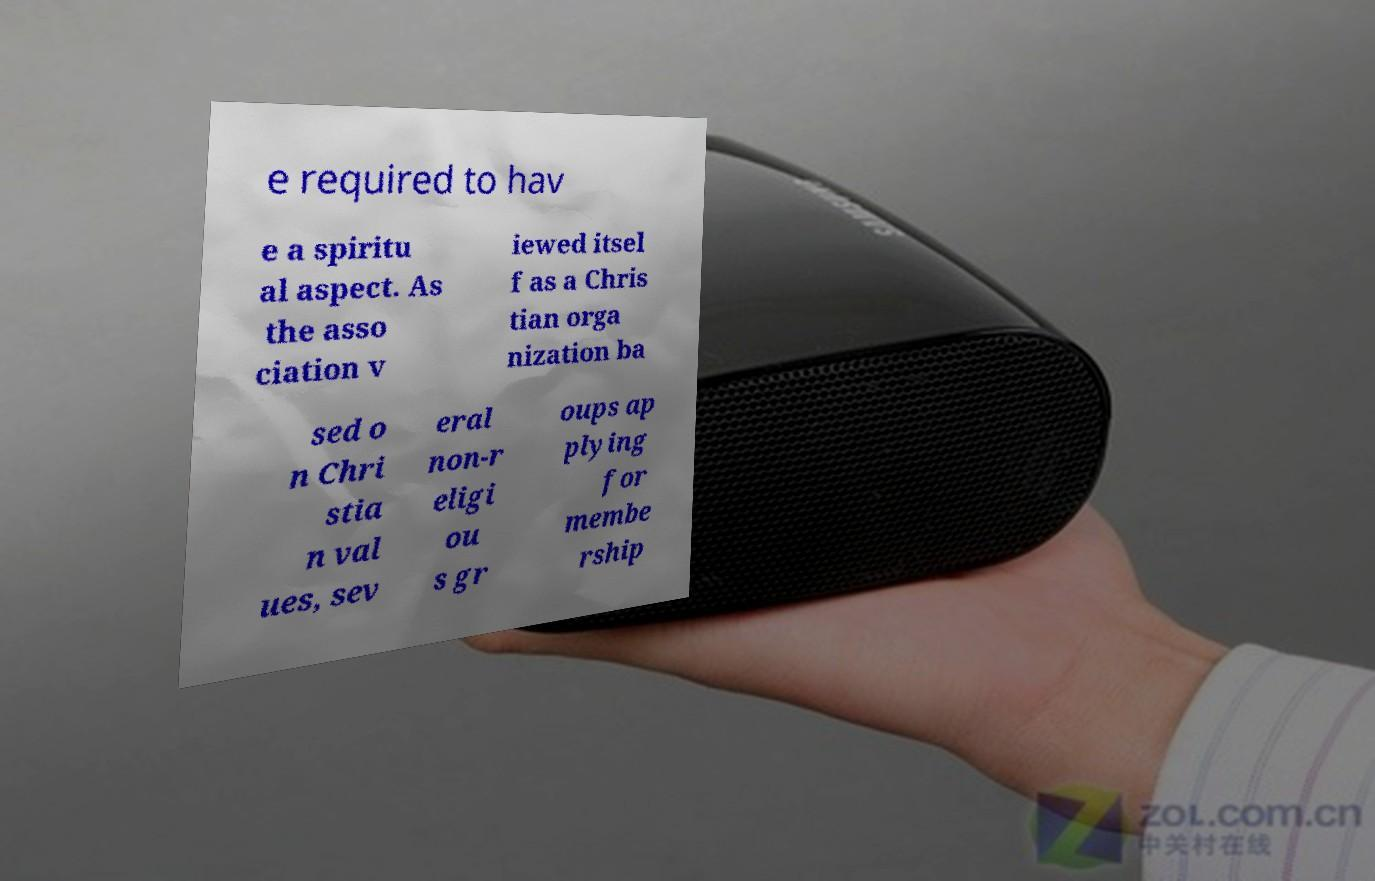Could you extract and type out the text from this image? e required to hav e a spiritu al aspect. As the asso ciation v iewed itsel f as a Chris tian orga nization ba sed o n Chri stia n val ues, sev eral non-r eligi ou s gr oups ap plying for membe rship 